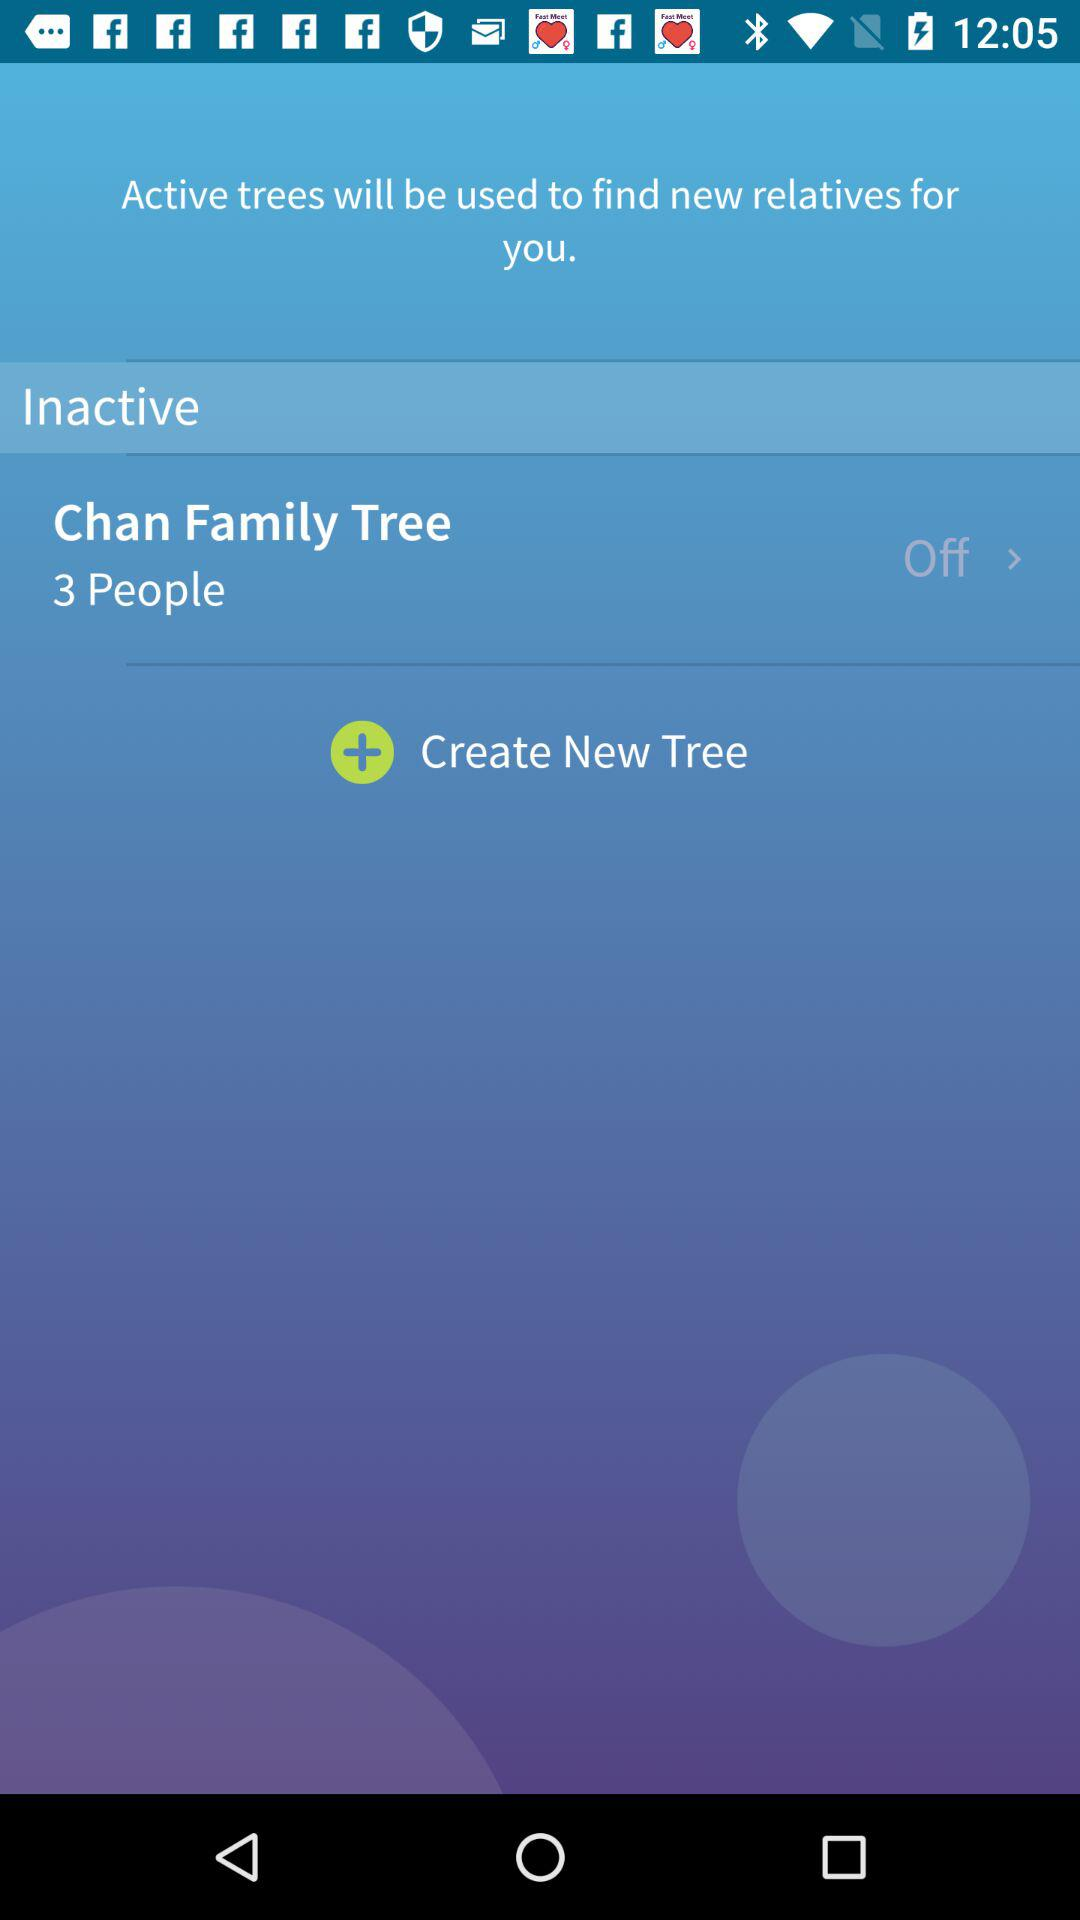How many people are in the Chan Family Tree?
Answer the question using a single word or phrase. 3 